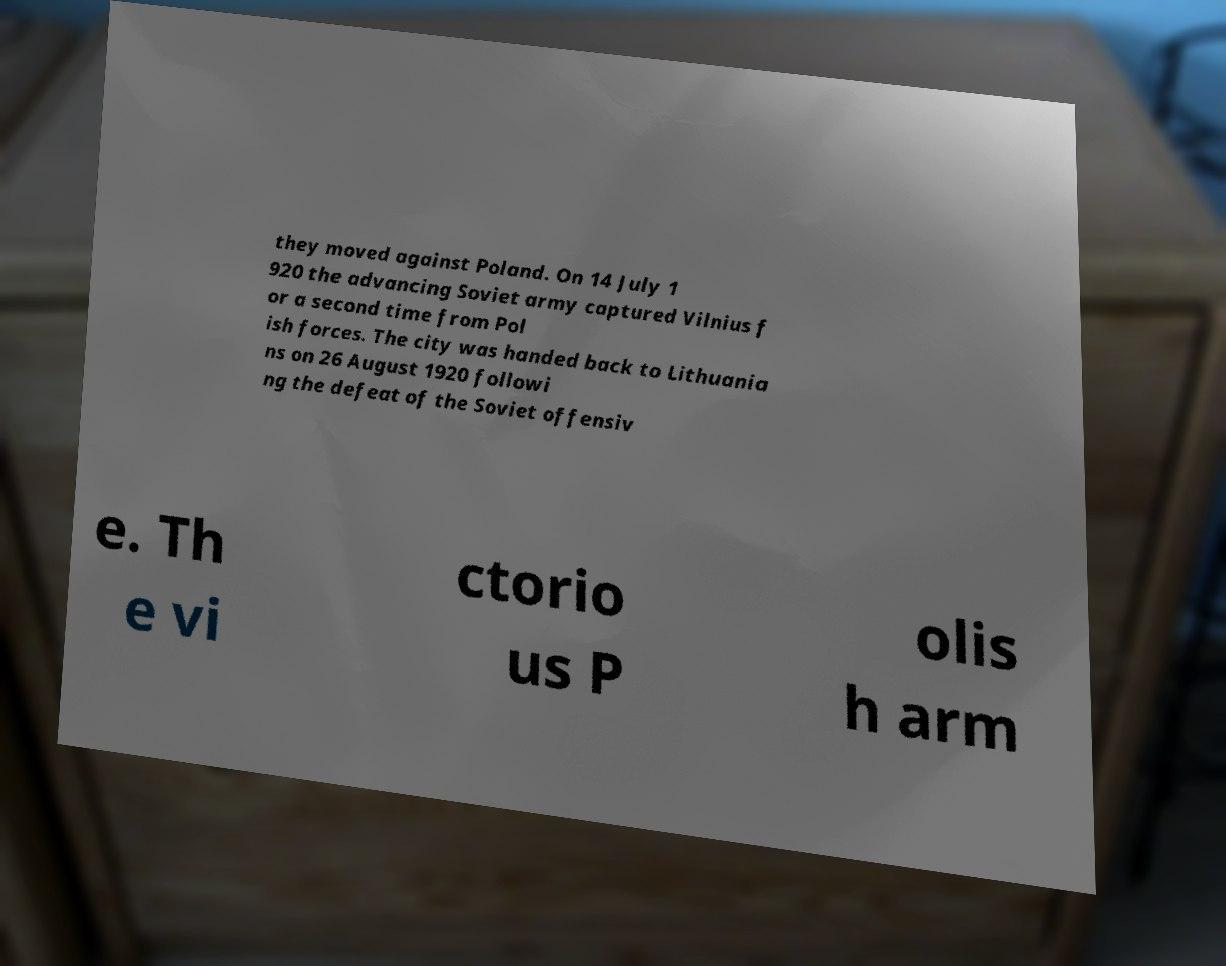Can you accurately transcribe the text from the provided image for me? they moved against Poland. On 14 July 1 920 the advancing Soviet army captured Vilnius f or a second time from Pol ish forces. The city was handed back to Lithuania ns on 26 August 1920 followi ng the defeat of the Soviet offensiv e. Th e vi ctorio us P olis h arm 